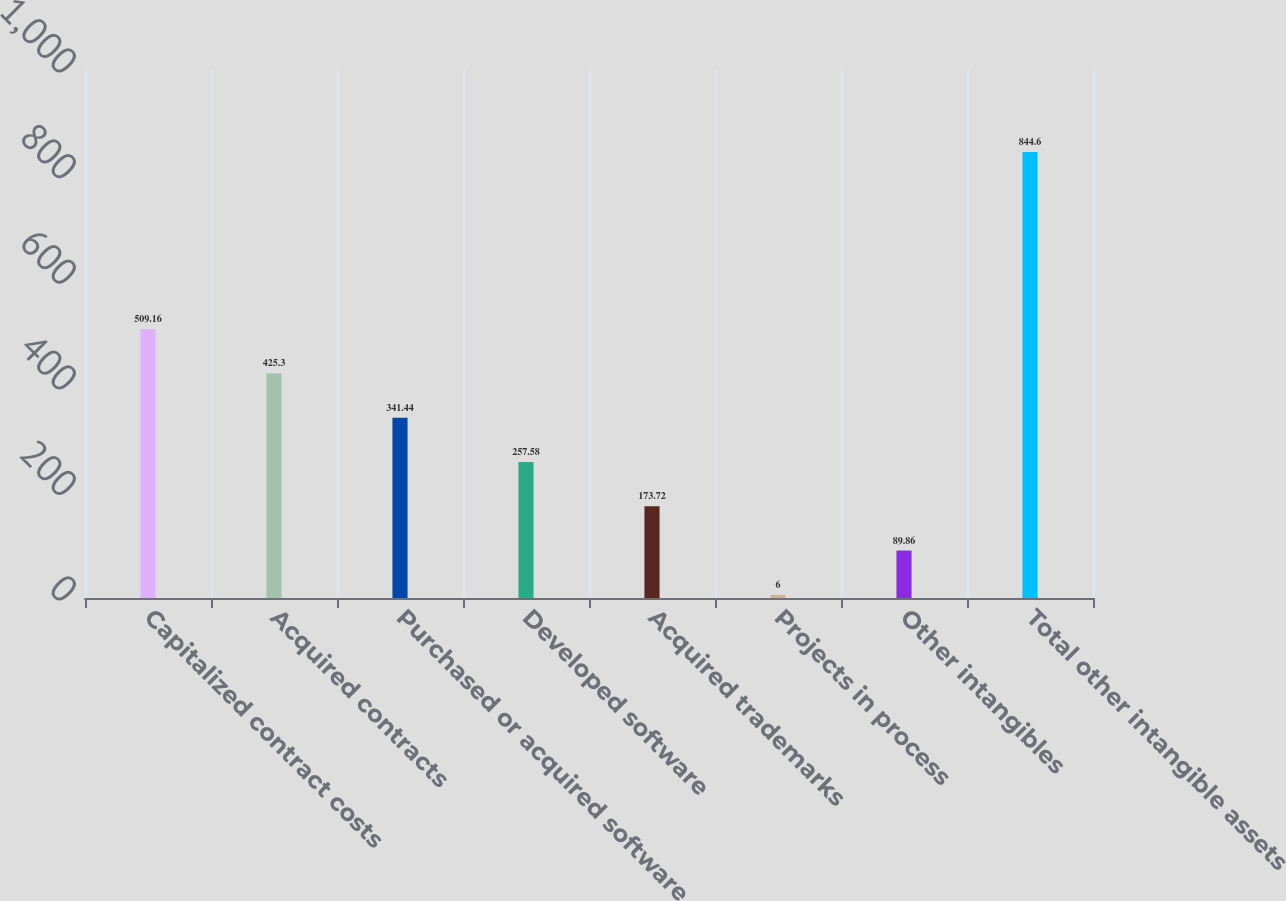Convert chart to OTSL. <chart><loc_0><loc_0><loc_500><loc_500><bar_chart><fcel>Capitalized contract costs<fcel>Acquired contracts<fcel>Purchased or acquired software<fcel>Developed software<fcel>Acquired trademarks<fcel>Projects in process<fcel>Other intangibles<fcel>Total other intangible assets<nl><fcel>509.16<fcel>425.3<fcel>341.44<fcel>257.58<fcel>173.72<fcel>6<fcel>89.86<fcel>844.6<nl></chart> 